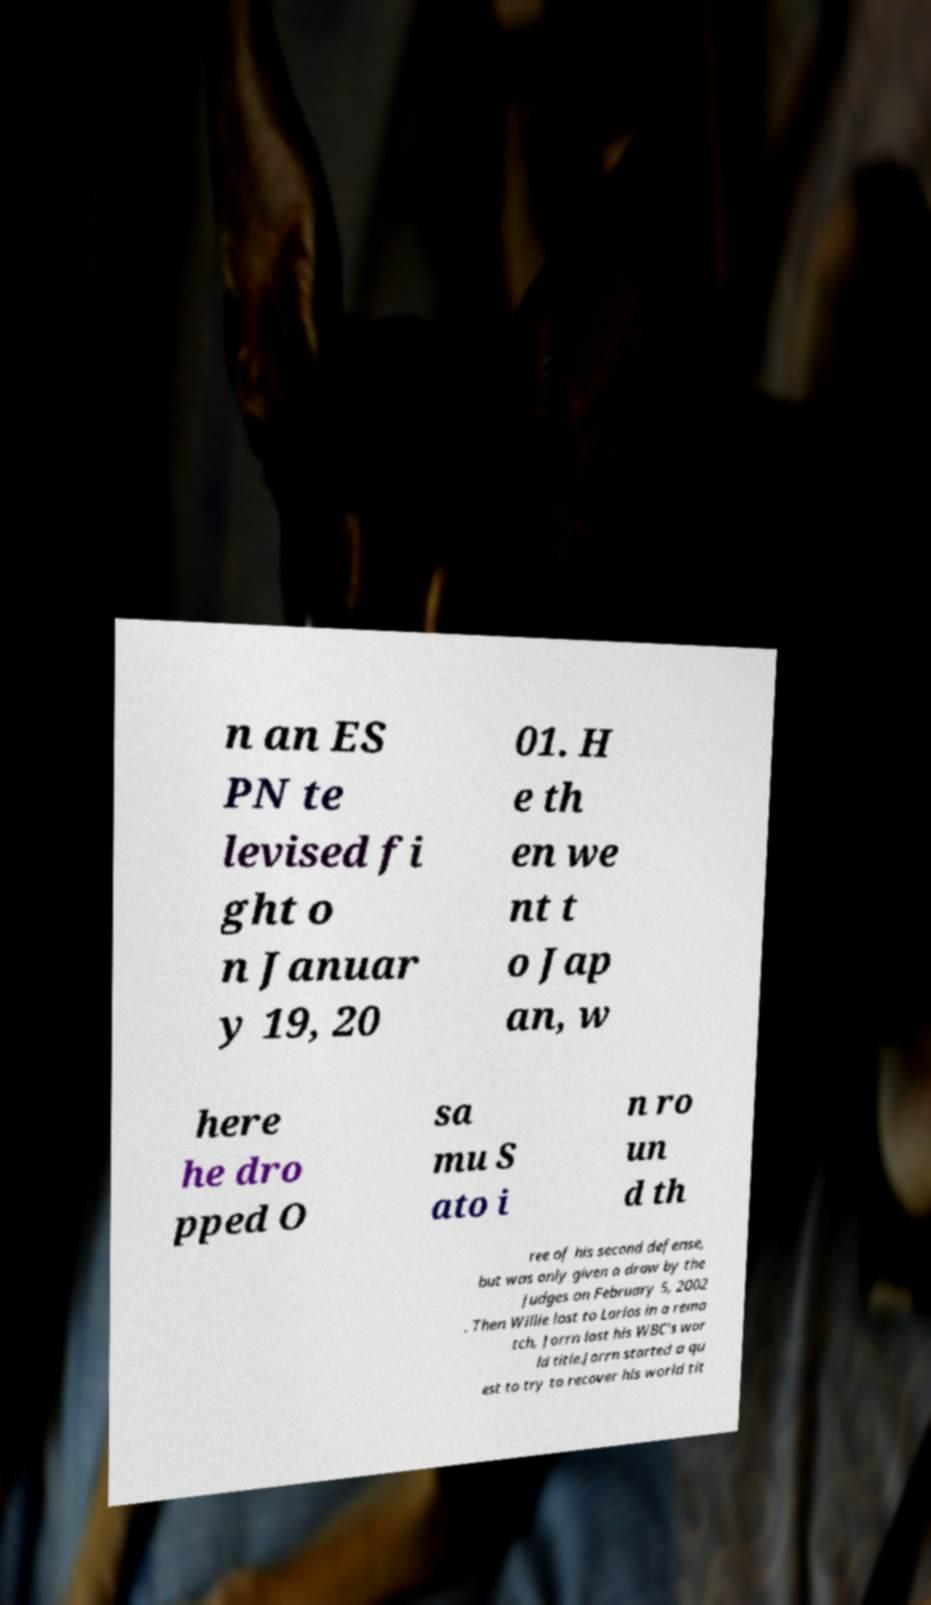There's text embedded in this image that I need extracted. Can you transcribe it verbatim? n an ES PN te levised fi ght o n Januar y 19, 20 01. H e th en we nt t o Jap an, w here he dro pped O sa mu S ato i n ro un d th ree of his second defense, but was only given a draw by the judges on February 5, 2002 . Then Willie lost to Larios in a rema tch, Jorrn lost his WBC's wor ld title.Jorrn started a qu est to try to recover his world tit 